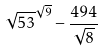<formula> <loc_0><loc_0><loc_500><loc_500>\sqrt { 5 3 } ^ { \sqrt { 9 } } - \frac { 4 9 4 } { \sqrt { 8 } }</formula> 